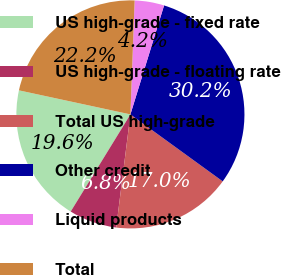<chart> <loc_0><loc_0><loc_500><loc_500><pie_chart><fcel>US high-grade - fixed rate<fcel>US high-grade - floating rate<fcel>Total US high-grade<fcel>Other credit<fcel>Liquid products<fcel>Total<nl><fcel>19.61%<fcel>6.78%<fcel>17.0%<fcel>30.22%<fcel>4.18%<fcel>22.21%<nl></chart> 